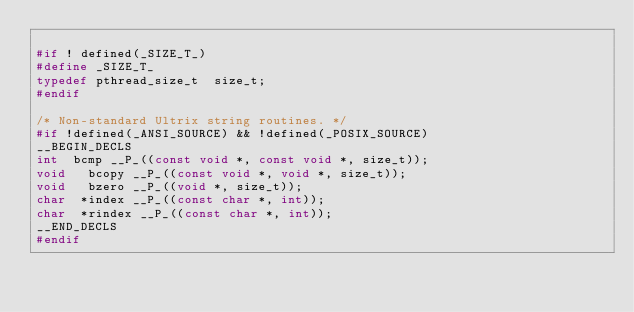<code> <loc_0><loc_0><loc_500><loc_500><_C_>
#if ! defined(_SIZE_T_)
#define _SIZE_T_
typedef pthread_size_t  size_t;
#endif

/* Non-standard Ultrix string routines. */
#if !defined(_ANSI_SOURCE) && !defined(_POSIX_SOURCE)
__BEGIN_DECLS
int	 bcmp __P_((const void *, const void *, size_t));
void	 bcopy __P_((const void *, void *, size_t));
void	 bzero __P_((void *, size_t));
char	*index __P_((const char *, int));
char	*rindex __P_((const char *, int));
__END_DECLS
#endif 

</code> 